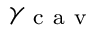<formula> <loc_0><loc_0><loc_500><loc_500>\gamma _ { c a v }</formula> 